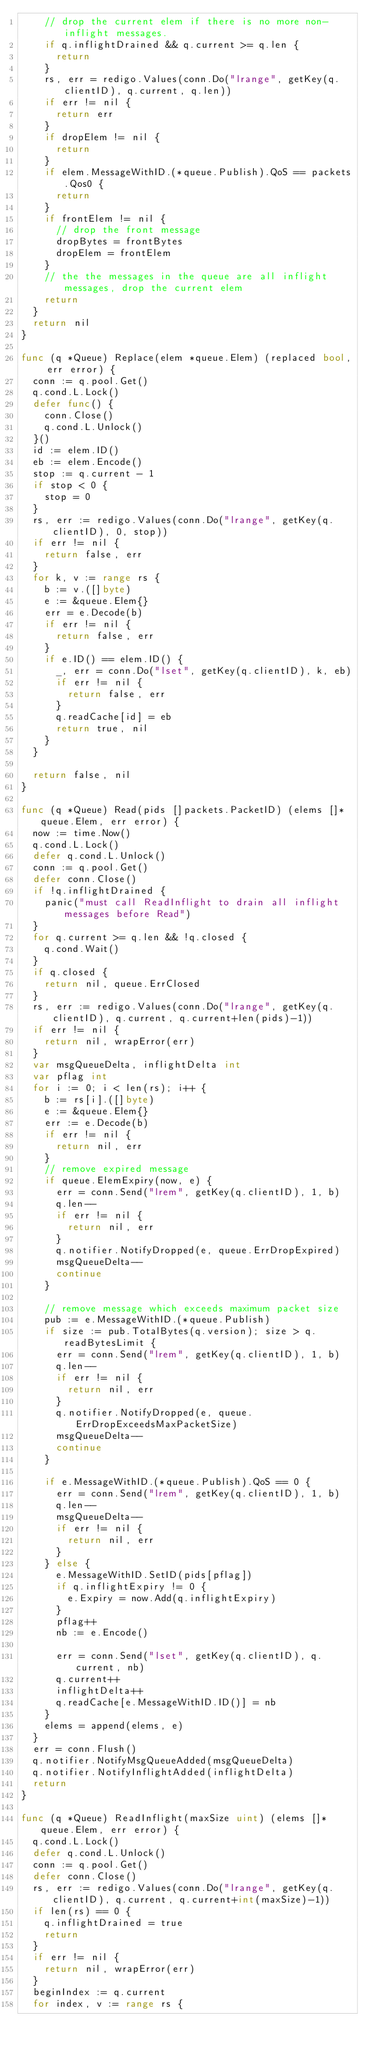<code> <loc_0><loc_0><loc_500><loc_500><_Go_>		// drop the current elem if there is no more non-inflight messages.
		if q.inflightDrained && q.current >= q.len {
			return
		}
		rs, err = redigo.Values(conn.Do("lrange", getKey(q.clientID), q.current, q.len))
		if err != nil {
			return err
		}
		if dropElem != nil {
			return
		}
		if elem.MessageWithID.(*queue.Publish).QoS == packets.Qos0 {
			return
		}
		if frontElem != nil {
			// drop the front message
			dropBytes = frontBytes
			dropElem = frontElem
		}
		// the the messages in the queue are all inflight messages, drop the current elem
		return
	}
	return nil
}

func (q *Queue) Replace(elem *queue.Elem) (replaced bool, err error) {
	conn := q.pool.Get()
	q.cond.L.Lock()
	defer func() {
		conn.Close()
		q.cond.L.Unlock()
	}()
	id := elem.ID()
	eb := elem.Encode()
	stop := q.current - 1
	if stop < 0 {
		stop = 0
	}
	rs, err := redigo.Values(conn.Do("lrange", getKey(q.clientID), 0, stop))
	if err != nil {
		return false, err
	}
	for k, v := range rs {
		b := v.([]byte)
		e := &queue.Elem{}
		err = e.Decode(b)
		if err != nil {
			return false, err
		}
		if e.ID() == elem.ID() {
			_, err = conn.Do("lset", getKey(q.clientID), k, eb)
			if err != nil {
				return false, err
			}
			q.readCache[id] = eb
			return true, nil
		}
	}

	return false, nil
}

func (q *Queue) Read(pids []packets.PacketID) (elems []*queue.Elem, err error) {
	now := time.Now()
	q.cond.L.Lock()
	defer q.cond.L.Unlock()
	conn := q.pool.Get()
	defer conn.Close()
	if !q.inflightDrained {
		panic("must call ReadInflight to drain all inflight messages before Read")
	}
	for q.current >= q.len && !q.closed {
		q.cond.Wait()
	}
	if q.closed {
		return nil, queue.ErrClosed
	}
	rs, err := redigo.Values(conn.Do("lrange", getKey(q.clientID), q.current, q.current+len(pids)-1))
	if err != nil {
		return nil, wrapError(err)
	}
	var msgQueueDelta, inflightDelta int
	var pflag int
	for i := 0; i < len(rs); i++ {
		b := rs[i].([]byte)
		e := &queue.Elem{}
		err := e.Decode(b)
		if err != nil {
			return nil, err
		}
		// remove expired message
		if queue.ElemExpiry(now, e) {
			err = conn.Send("lrem", getKey(q.clientID), 1, b)
			q.len--
			if err != nil {
				return nil, err
			}
			q.notifier.NotifyDropped(e, queue.ErrDropExpired)
			msgQueueDelta--
			continue
		}

		// remove message which exceeds maximum packet size
		pub := e.MessageWithID.(*queue.Publish)
		if size := pub.TotalBytes(q.version); size > q.readBytesLimit {
			err = conn.Send("lrem", getKey(q.clientID), 1, b)
			q.len--
			if err != nil {
				return nil, err
			}
			q.notifier.NotifyDropped(e, queue.ErrDropExceedsMaxPacketSize)
			msgQueueDelta--
			continue
		}

		if e.MessageWithID.(*queue.Publish).QoS == 0 {
			err = conn.Send("lrem", getKey(q.clientID), 1, b)
			q.len--
			msgQueueDelta--
			if err != nil {
				return nil, err
			}
		} else {
			e.MessageWithID.SetID(pids[pflag])
			if q.inflightExpiry != 0 {
				e.Expiry = now.Add(q.inflightExpiry)
			}
			pflag++
			nb := e.Encode()

			err = conn.Send("lset", getKey(q.clientID), q.current, nb)
			q.current++
			inflightDelta++
			q.readCache[e.MessageWithID.ID()] = nb
		}
		elems = append(elems, e)
	}
	err = conn.Flush()
	q.notifier.NotifyMsgQueueAdded(msgQueueDelta)
	q.notifier.NotifyInflightAdded(inflightDelta)
	return
}

func (q *Queue) ReadInflight(maxSize uint) (elems []*queue.Elem, err error) {
	q.cond.L.Lock()
	defer q.cond.L.Unlock()
	conn := q.pool.Get()
	defer conn.Close()
	rs, err := redigo.Values(conn.Do("lrange", getKey(q.clientID), q.current, q.current+int(maxSize)-1))
	if len(rs) == 0 {
		q.inflightDrained = true
		return
	}
	if err != nil {
		return nil, wrapError(err)
	}
	beginIndex := q.current
	for index, v := range rs {</code> 